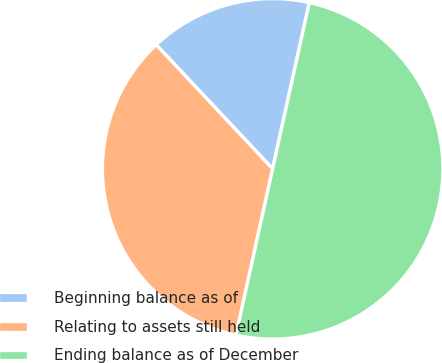Convert chart to OTSL. <chart><loc_0><loc_0><loc_500><loc_500><pie_chart><fcel>Beginning balance as of<fcel>Relating to assets still held<fcel>Ending balance as of December<nl><fcel>15.45%<fcel>34.55%<fcel>50.0%<nl></chart> 